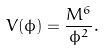<formula> <loc_0><loc_0><loc_500><loc_500>V ( \phi ) = \frac { M ^ { 6 } } { \phi ^ { 2 } } .</formula> 